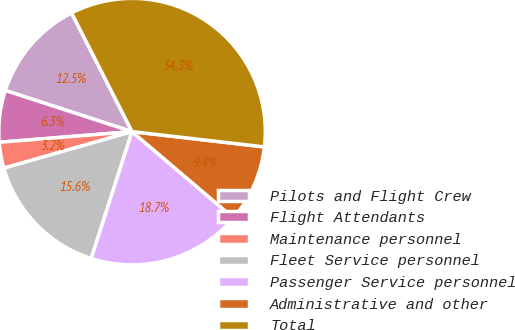<chart> <loc_0><loc_0><loc_500><loc_500><pie_chart><fcel>Pilots and Flight Crew<fcel>Flight Attendants<fcel>Maintenance personnel<fcel>Fleet Service personnel<fcel>Passenger Service personnel<fcel>Administrative and other<fcel>Total<nl><fcel>12.5%<fcel>6.27%<fcel>3.15%<fcel>15.62%<fcel>18.74%<fcel>9.39%<fcel>34.33%<nl></chart> 